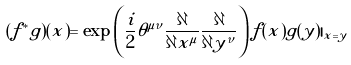<formula> <loc_0><loc_0><loc_500><loc_500>( f ^ { * } g ) ( x ) = \exp \left ( \frac { i } { 2 } \theta ^ { \mu \nu } \frac { \partial } { \partial x ^ { \mu } } \frac { \partial } { \partial y ^ { \nu } } \right ) f ( x ) g ( y ) | _ { x = y }</formula> 